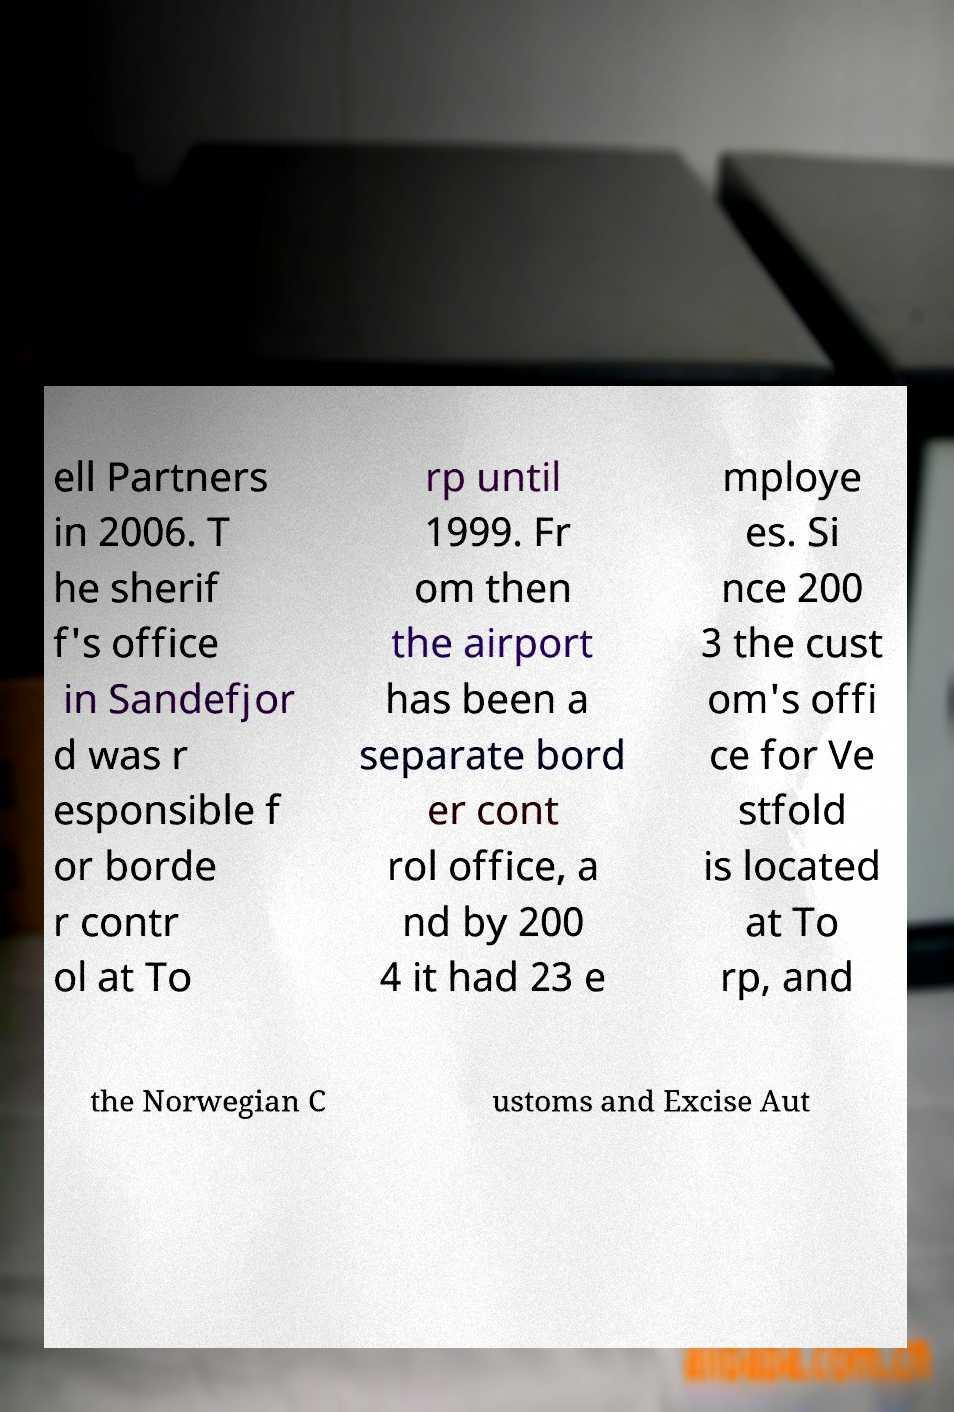There's text embedded in this image that I need extracted. Can you transcribe it verbatim? ell Partners in 2006. T he sherif f's office in Sandefjor d was r esponsible f or borde r contr ol at To rp until 1999. Fr om then the airport has been a separate bord er cont rol office, a nd by 200 4 it had 23 e mploye es. Si nce 200 3 the cust om's offi ce for Ve stfold is located at To rp, and the Norwegian C ustoms and Excise Aut 